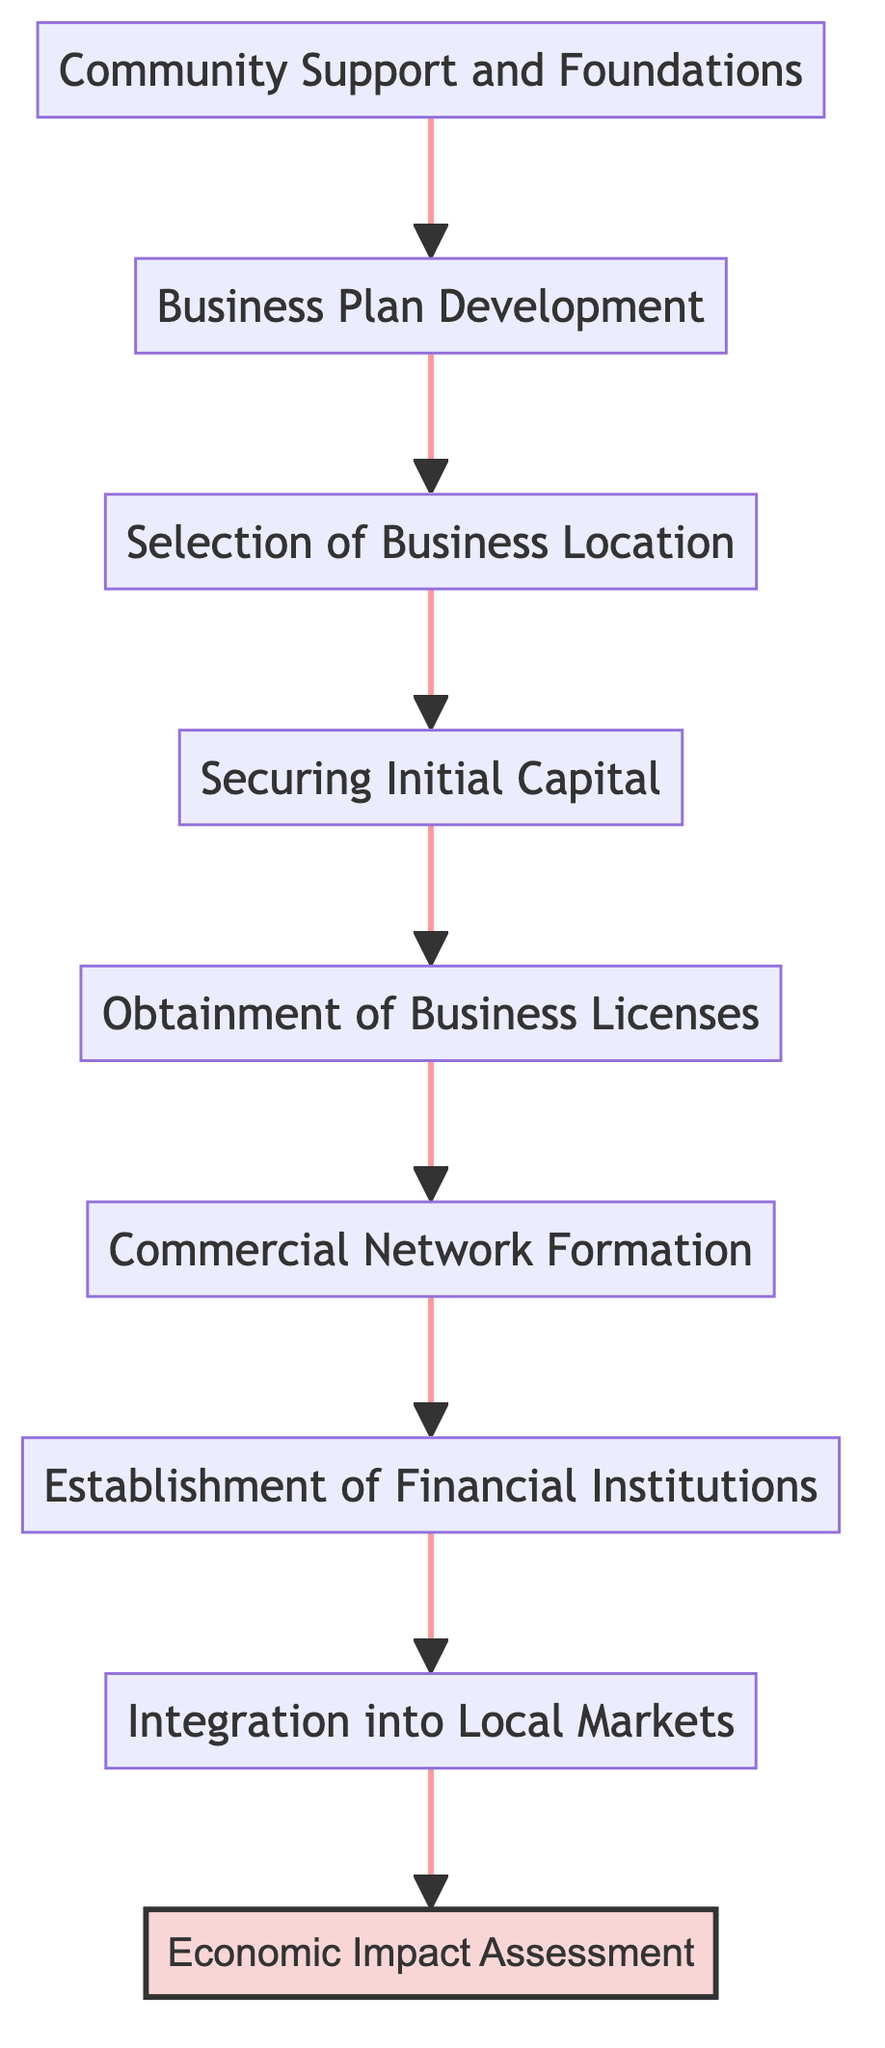What is the first step in establishing Jewish-owned businesses in the Confederacy? The first step in the flow chart is "Community Support and Foundations," which indicates that leveraging community support is necessary before any other activities can begin.
Answer: Community Support and Foundations How many nodes are present in the diagram? By counting each individual step from the bottom to the top, we find there are a total of nine nodes: Community Support and Foundations, Business Plan Development, Selection of Business Location, Securing Initial Capital, Obtainment of Business Licenses, Commercial Network Formation, Establishment of Financial Institutions, Integration into Local Markets, and Economic Impact Assessment.
Answer: Nine What comes after "Securing Initial Capital"? The node that follows "Securing Initial Capital" in the flow from bottom to top is "Obtainment of Business Licenses," indicating that securing funding is a precursor to obtaining the legal permits needed to operate a business.
Answer: Obtainment of Business Licenses Which step directly leads to the "Economic Impact Assessment"? The direct predecessor step to the "Economic Impact Assessment" is "Integration into Local Markets." This means that before evaluating economic impacts, the businesses must first be integrated into the local economic frameworks.
Answer: Integration into Local Markets What is the significance of "Establishment of Financial Institutions" in the process? This step is critical as it emphasizes the need for Jewish entrepreneurs to create financial services that not only support their own businesses but also contribute to the broader economic activities within the Confederacy. It comes after "Commercial Network Formation," suggesting that a collaborative merchant environment facilitates the need for banking services.
Answer: Critical support for businesses 